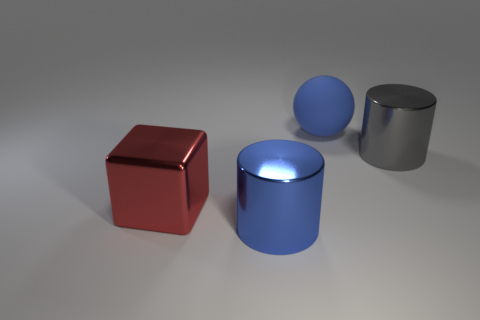Add 4 green matte cylinders. How many objects exist? 8 Add 2 metal things. How many metal things are left? 5 Add 4 tiny rubber blocks. How many tiny rubber blocks exist? 4 Subtract 1 blue balls. How many objects are left? 3 Subtract 1 cylinders. How many cylinders are left? 1 Subtract all red cylinders. Subtract all cyan cubes. How many cylinders are left? 2 Subtract all green balls. How many purple cylinders are left? 0 Subtract all tiny blue things. Subtract all big blue shiny cylinders. How many objects are left? 3 